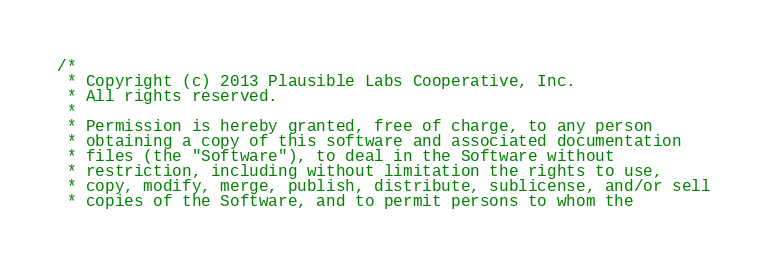<code> <loc_0><loc_0><loc_500><loc_500><_C++_>/*
 * Copyright (c) 2013 Plausible Labs Cooperative, Inc.
 * All rights reserved.
 *
 * Permission is hereby granted, free of charge, to any person
 * obtaining a copy of this software and associated documentation
 * files (the "Software"), to deal in the Software without
 * restriction, including without limitation the rights to use,
 * copy, modify, merge, publish, distribute, sublicense, and/or sell
 * copies of the Software, and to permit persons to whom the</code> 